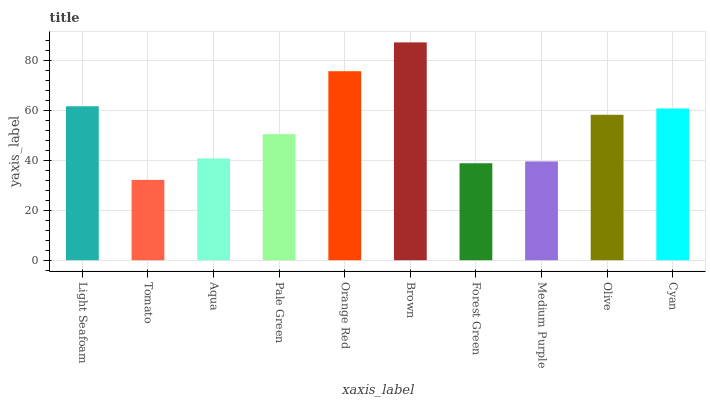Is Aqua the minimum?
Answer yes or no. No. Is Aqua the maximum?
Answer yes or no. No. Is Aqua greater than Tomato?
Answer yes or no. Yes. Is Tomato less than Aqua?
Answer yes or no. Yes. Is Tomato greater than Aqua?
Answer yes or no. No. Is Aqua less than Tomato?
Answer yes or no. No. Is Olive the high median?
Answer yes or no. Yes. Is Pale Green the low median?
Answer yes or no. Yes. Is Tomato the high median?
Answer yes or no. No. Is Light Seafoam the low median?
Answer yes or no. No. 